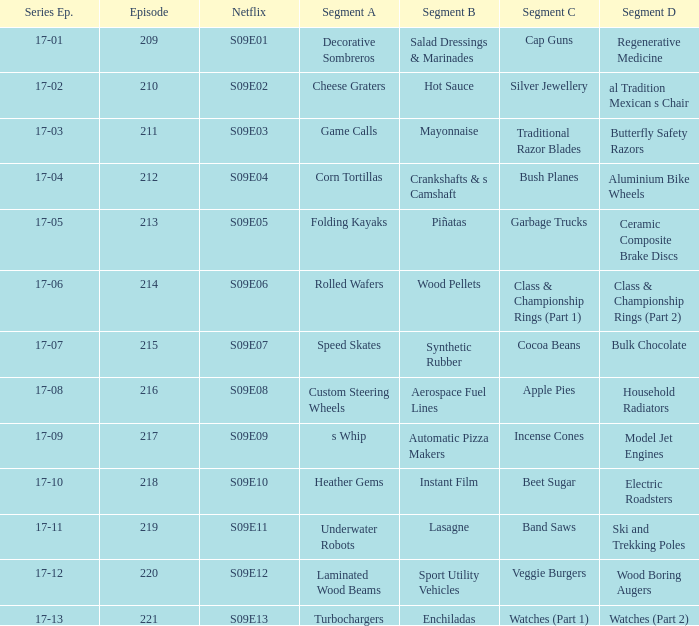Segment B of aerospace fuel lines has what segment A? Custom Steering Wheels. 